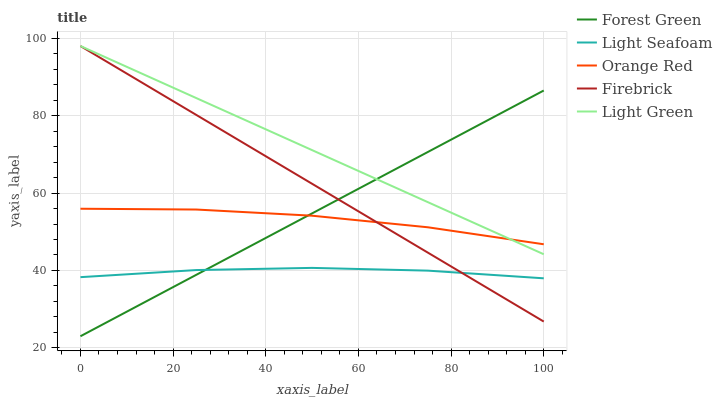Does Light Seafoam have the minimum area under the curve?
Answer yes or no. Yes. Does Light Green have the maximum area under the curve?
Answer yes or no. Yes. Does Forest Green have the minimum area under the curve?
Answer yes or no. No. Does Forest Green have the maximum area under the curve?
Answer yes or no. No. Is Light Green the smoothest?
Answer yes or no. Yes. Is Orange Red the roughest?
Answer yes or no. Yes. Is Forest Green the smoothest?
Answer yes or no. No. Is Forest Green the roughest?
Answer yes or no. No. Does Light Seafoam have the lowest value?
Answer yes or no. No. Does Light Green have the highest value?
Answer yes or no. Yes. Does Forest Green have the highest value?
Answer yes or no. No. Is Light Seafoam less than Orange Red?
Answer yes or no. Yes. Is Light Green greater than Light Seafoam?
Answer yes or no. Yes. Does Light Seafoam intersect Orange Red?
Answer yes or no. No. 